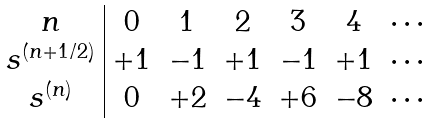<formula> <loc_0><loc_0><loc_500><loc_500>\begin{array} { c | c c c c c c } n & 0 & 1 & 2 & 3 & 4 & \cdots \\ s ^ { ( n + 1 / 2 ) } & + 1 & - 1 & + 1 & - 1 & + 1 & \cdots \\ s ^ { ( n ) } & 0 & + 2 & - 4 & + 6 & - 8 & \cdots \end{array}</formula> 